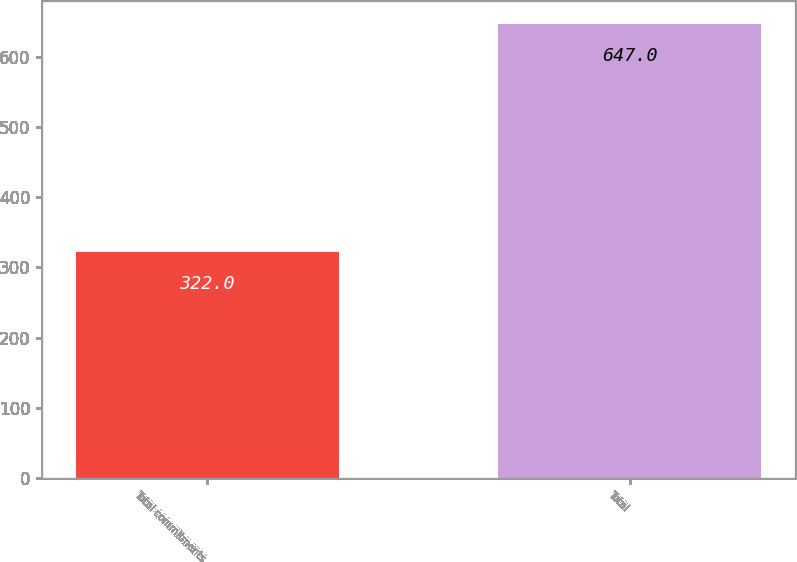Convert chart to OTSL. <chart><loc_0><loc_0><loc_500><loc_500><bar_chart><fcel>Total commitments<fcel>Total<nl><fcel>322<fcel>647<nl></chart> 